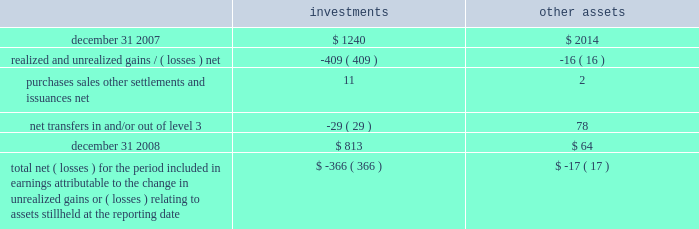A wholly-owned subsidiary of the company is a registered life insurance company that maintains separate account assets , representing segregated funds held for purposes of funding individual and group pension contracts , and equal and offsetting separate account liabilities .
At decem - ber 31 , 2008 and 2007 , the level 3 separate account assets were approximately $ 4 and $ 12 , respectively .
The changes in level 3 assets primarily relate to purchases , sales and gains/ ( losses ) .
The net investment income and net gains and losses attributable to separate account assets accrue directly to the contract owner and are not reported as non-operating income ( expense ) on the consolidated statements of income .
Level 3 assets , which includes equity method investments or consolidated investments of real estate funds , private equity funds and funds of private equity funds are valued based upon valuations received from internal as well as third party fund managers .
Fair valuations at the underlying funds are based on a combination of methods which may include third-party independent appraisals and discounted cash flow techniques .
Direct investments in private equity companies held by funds of private equity funds are valued based on an assessment of each under - lying investment , incorporating evaluation of additional significant third party financing , changes in valuations of comparable peer companies and the business environment of the companies , among other factors .
See note 2 for further detail on the fair value policies by the underlying funds .
Changes in level 3 assets measured at fair value on a recurring basis for the year ended december 31 , 2008 .
Total net ( losses ) for the period included in earnings attributable to the change in unrealized gains or ( losses ) relating to assets still held at the reporting date $ ( 366 ) $ ( 17 ) realized and unrealized gains and losses recorded for level 3 assets are reported in non-operating income ( expense ) on the consolidated statements of income .
Non-controlling interest expense is recorded for consoli- dated investments to reflect the portion of gains and losses not attributable to the company .
The company transfers assets in and/or out of level 3 as significant inputs , including performance attributes , used for the fair value measurement become observable .
Variable interest entities in the normal course of business , the company is the manager of various types of sponsored investment vehicles , including collateralized debt obligations and sponsored investment funds , that may be considered vies .
The company receives management fees or other incen- tive related fees for its services and may from time to time own equity or debt securities or enter into derivatives with the vehicles , each of which are considered variable inter- ests .
The company engages in these variable interests principally to address client needs through the launch of such investment vehicles .
The vies are primarily financed via capital contributed by equity and debt holders .
The company 2019s involvement in financing the operations of the vies is limited to its equity interests , unfunded capital commitments for certain sponsored investment funds and its capital support agreements for two enhanced cash funds .
The primary beneficiary of a vie is the party that absorbs a majority of the entity 2019s expected losses , receives a major - ity of the entity 2019s expected residual returns or both as a result of holding variable interests .
In order to determine whether the company is the primary beneficiary of a vie , management must make significant estimates and assumptions of probable future cash flows and assign probabilities to different cash flow scenarios .
Assumptions made in such analyses include , but are not limited to , market prices of securities , market interest rates , poten- tial credit defaults on individual securities or default rates on a portfolio of securities , gain realization , liquidity or marketability of certain securities , discount rates and the probability of certain other outcomes .
Vies in which blackrock is the primary beneficiary at december 31 , 2008 , the company was the primary beneficiary of three vies , which resulted in consolidation of three sponsored investment funds ( including two cash management funds and one private equity fund of funds ) .
Creditors of the vies do not have recourse to the credit of the company .
During 2008 , the company determined it became the primary beneficiary of two enhanced cash management funds as a result of concluding that under various cash 177528_txt_59_96:layout 1 3/26/09 10:32 pm page 73 .
What is the net change in the balance of level 3 investments assets during 2008? 
Computations: (813 - 1240)
Answer: -427.0. 